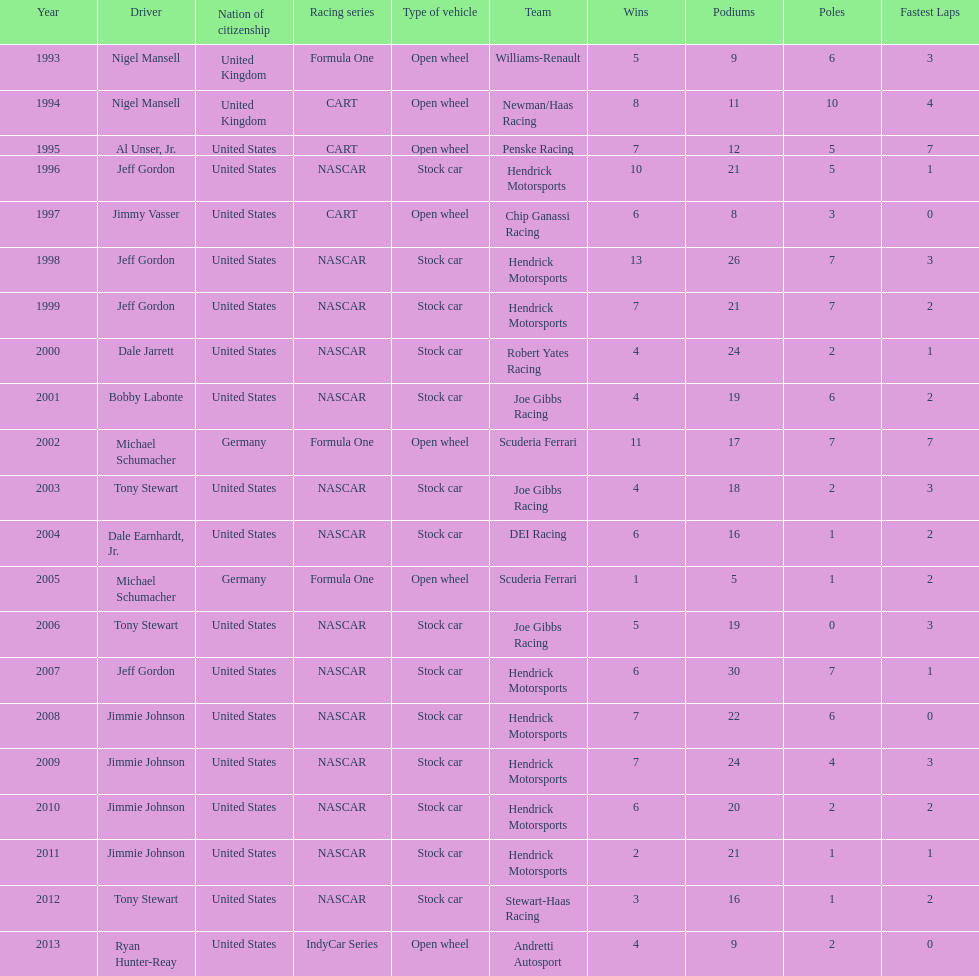Which driver had four consecutive wins? Jimmie Johnson. 